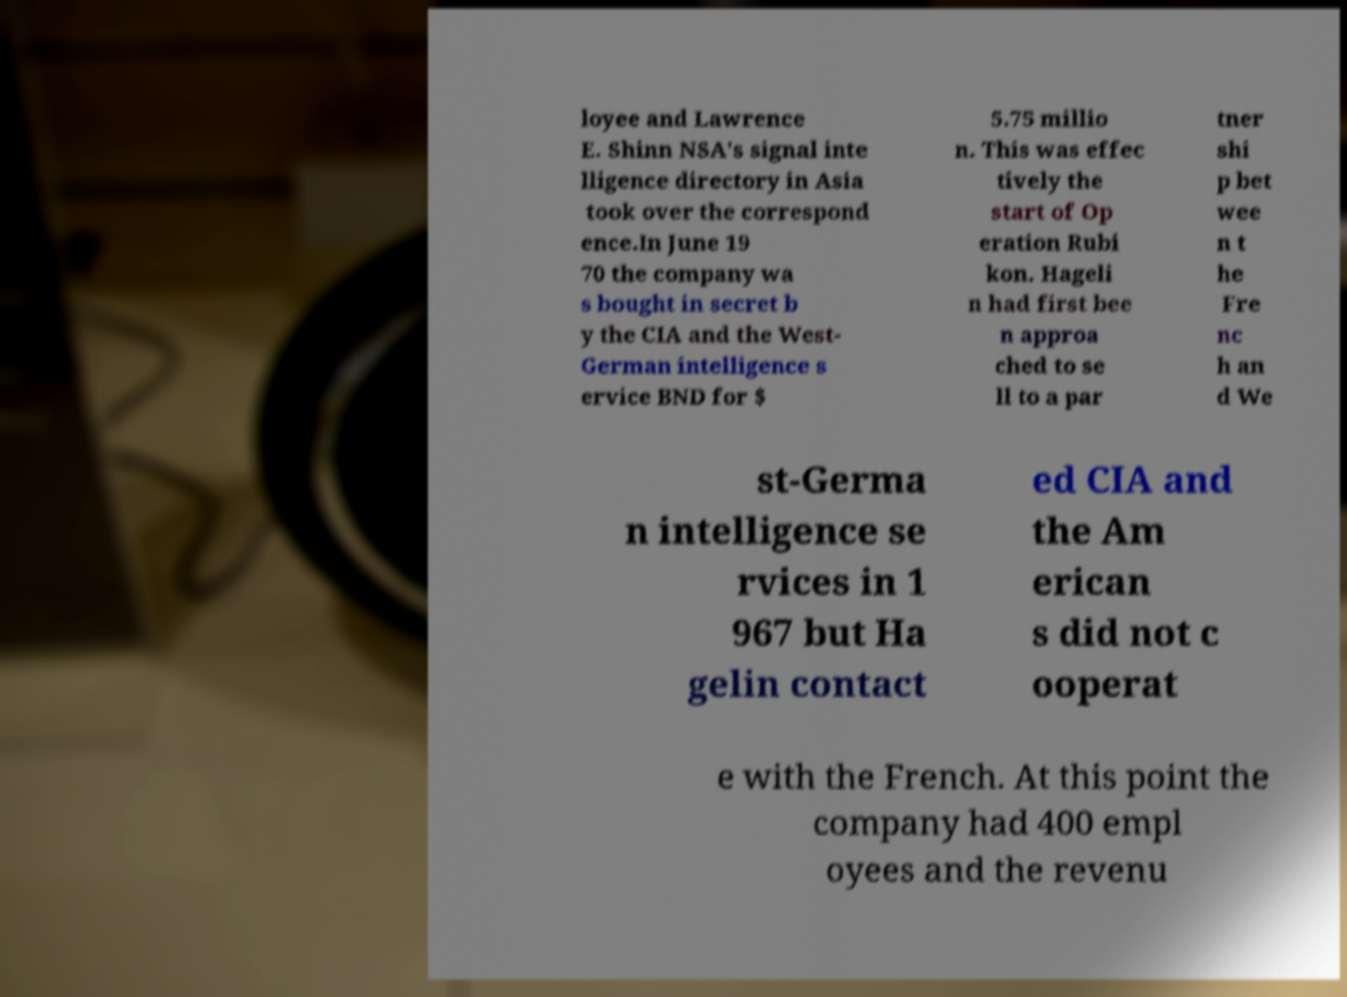Could you assist in decoding the text presented in this image and type it out clearly? loyee and Lawrence E. Shinn NSA's signal inte lligence directory in Asia took over the correspond ence.In June 19 70 the company wa s bought in secret b y the CIA and the West- German intelligence s ervice BND for $ 5.75 millio n. This was effec tively the start of Op eration Rubi kon. Hageli n had first bee n approa ched to se ll to a par tner shi p bet wee n t he Fre nc h an d We st-Germa n intelligence se rvices in 1 967 but Ha gelin contact ed CIA and the Am erican s did not c ooperat e with the French. At this point the company had 400 empl oyees and the revenu 